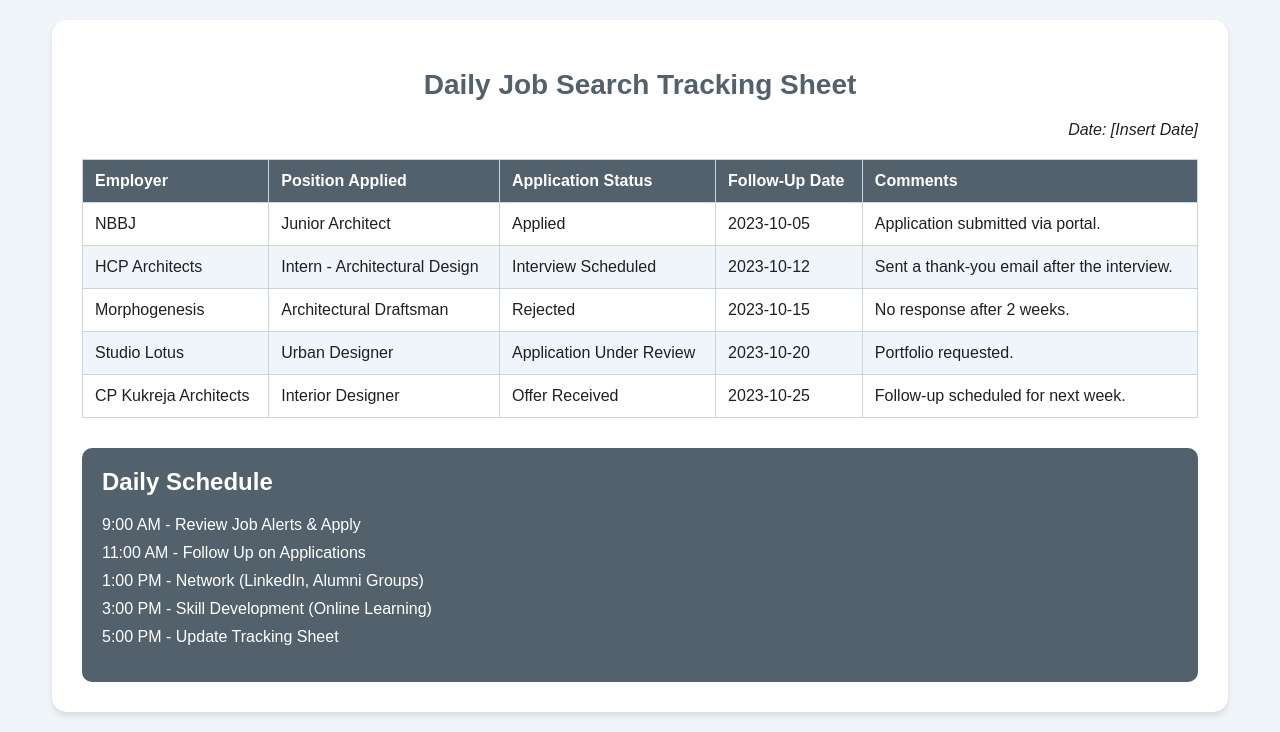What is the date of the scheduled follow-up for NBBJ? The follow-up date for NBBJ is extracted from the table under the "Follow-Up Date" column for the respective employer, which is 2023-10-05.
Answer: 2023-10-05 What position did HCP Architects advertise? This information can be found in the "Position Applied" column for HCP Architects, which indicates "Intern - Architectural Design."
Answer: Intern - Architectural Design How many applications have been rejected? The document lists the statuses of all applications; the number of rejections can be counted from the table, which shows one rejection for Morphogenesis.
Answer: 1 What is the follow-up date for the offer received from CP Kukreja Architects? This is found under the "Follow-Up Date" column corresponding to CP Kukreja Architects, which is 2023-10-25.
Answer: 2023-10-25 What time is scheduled for skill development in the daily schedule? The specific time is listed in the daily schedule section, where it shows skill development at 3:00 PM.
Answer: 3:00 PM Why was Morphogenesis's application status marked as rejected? The explanation for the rejection is provided in the "Comments" column, stating "No response after 2 weeks."
Answer: No response after 2 weeks Who sent a thank-you email after the interview? The document provides details in the comments section for HCP Architects, clearly mentioning that a thank-you email was sent.
Answer: HCP Architects What is the color of the table header? The header colors are specified in the style section, identifying the table header's background color as #52616b.
Answer: #52616b 